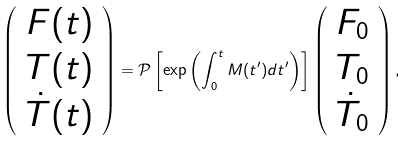Convert formula to latex. <formula><loc_0><loc_0><loc_500><loc_500>\left ( \begin{array} { c } F ( t ) \\ T ( t ) \\ \dot { T } ( t ) \\ \end{array} \right ) = \mathcal { P } \left [ \exp \left ( \int _ { 0 } ^ { t } M ( t ^ { \prime } ) d t ^ { \prime } \right ) \right ] \left ( \begin{array} { c } F _ { 0 } \\ T _ { 0 } \\ \dot { T } _ { 0 } \\ \end{array} \right ) ,</formula> 